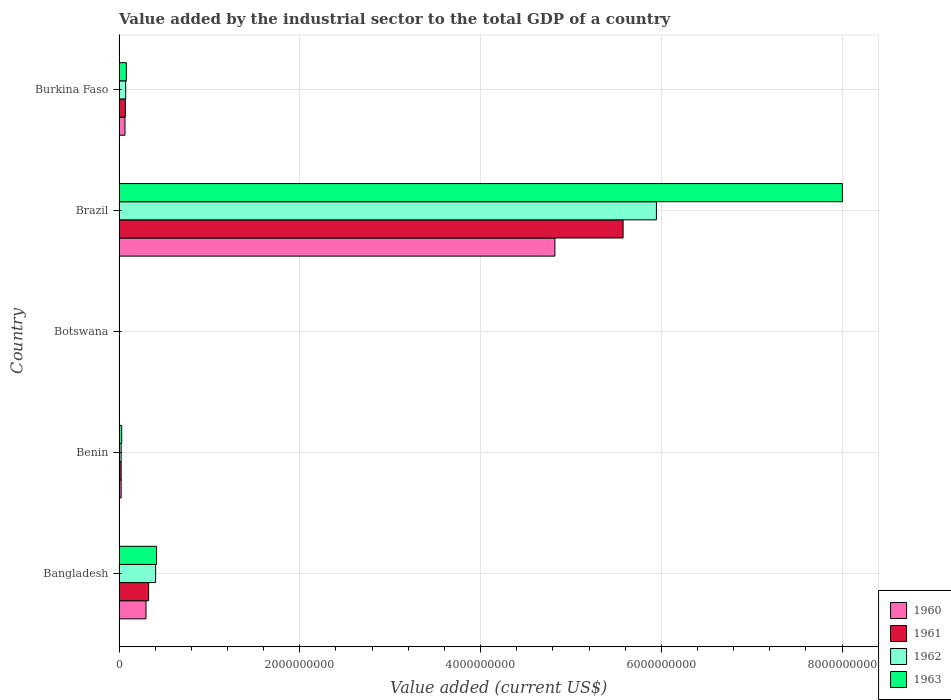What is the label of the 4th group of bars from the top?
Offer a terse response. Benin. In how many cases, is the number of bars for a given country not equal to the number of legend labels?
Keep it short and to the point. 0. What is the value added by the industrial sector to the total GDP in 1960 in Bangladesh?
Keep it short and to the point. 2.98e+08. Across all countries, what is the maximum value added by the industrial sector to the total GDP in 1963?
Your answer should be compact. 8.00e+09. Across all countries, what is the minimum value added by the industrial sector to the total GDP in 1961?
Ensure brevity in your answer.  4.05e+06. In which country was the value added by the industrial sector to the total GDP in 1960 maximum?
Offer a very short reply. Brazil. In which country was the value added by the industrial sector to the total GDP in 1960 minimum?
Provide a short and direct response. Botswana. What is the total value added by the industrial sector to the total GDP in 1960 in the graph?
Make the answer very short. 5.21e+09. What is the difference between the value added by the industrial sector to the total GDP in 1961 in Botswana and that in Burkina Faso?
Provide a succinct answer. -6.56e+07. What is the difference between the value added by the industrial sector to the total GDP in 1963 in Bangladesh and the value added by the industrial sector to the total GDP in 1961 in Benin?
Keep it short and to the point. 3.92e+08. What is the average value added by the industrial sector to the total GDP in 1963 per country?
Provide a succinct answer. 1.71e+09. What is the difference between the value added by the industrial sector to the total GDP in 1960 and value added by the industrial sector to the total GDP in 1962 in Botswana?
Offer a very short reply. -314.81. In how many countries, is the value added by the industrial sector to the total GDP in 1963 greater than 4000000000 US$?
Ensure brevity in your answer.  1. What is the ratio of the value added by the industrial sector to the total GDP in 1962 in Bangladesh to that in Botswana?
Provide a succinct answer. 99.81. Is the value added by the industrial sector to the total GDP in 1961 in Bangladesh less than that in Botswana?
Keep it short and to the point. No. Is the difference between the value added by the industrial sector to the total GDP in 1960 in Bangladesh and Burkina Faso greater than the difference between the value added by the industrial sector to the total GDP in 1962 in Bangladesh and Burkina Faso?
Make the answer very short. No. What is the difference between the highest and the second highest value added by the industrial sector to the total GDP in 1962?
Make the answer very short. 5.54e+09. What is the difference between the highest and the lowest value added by the industrial sector to the total GDP in 1963?
Make the answer very short. 8.00e+09. In how many countries, is the value added by the industrial sector to the total GDP in 1962 greater than the average value added by the industrial sector to the total GDP in 1962 taken over all countries?
Keep it short and to the point. 1. Is the sum of the value added by the industrial sector to the total GDP in 1962 in Botswana and Burkina Faso greater than the maximum value added by the industrial sector to the total GDP in 1960 across all countries?
Your response must be concise. No. Is it the case that in every country, the sum of the value added by the industrial sector to the total GDP in 1960 and value added by the industrial sector to the total GDP in 1962 is greater than the sum of value added by the industrial sector to the total GDP in 1961 and value added by the industrial sector to the total GDP in 1963?
Provide a short and direct response. No. What does the 2nd bar from the top in Bangladesh represents?
Make the answer very short. 1962. Is it the case that in every country, the sum of the value added by the industrial sector to the total GDP in 1960 and value added by the industrial sector to the total GDP in 1962 is greater than the value added by the industrial sector to the total GDP in 1961?
Your answer should be very brief. Yes. How many bars are there?
Your answer should be very brief. 20. What is the difference between two consecutive major ticks on the X-axis?
Provide a short and direct response. 2.00e+09. Does the graph contain any zero values?
Offer a terse response. No. Does the graph contain grids?
Your response must be concise. Yes. Where does the legend appear in the graph?
Provide a succinct answer. Bottom right. How many legend labels are there?
Your response must be concise. 4. What is the title of the graph?
Your answer should be compact. Value added by the industrial sector to the total GDP of a country. Does "1988" appear as one of the legend labels in the graph?
Ensure brevity in your answer.  No. What is the label or title of the X-axis?
Your answer should be very brief. Value added (current US$). What is the Value added (current US$) of 1960 in Bangladesh?
Give a very brief answer. 2.98e+08. What is the Value added (current US$) in 1961 in Bangladesh?
Make the answer very short. 3.27e+08. What is the Value added (current US$) in 1962 in Bangladesh?
Ensure brevity in your answer.  4.05e+08. What is the Value added (current US$) in 1963 in Bangladesh?
Provide a succinct answer. 4.15e+08. What is the Value added (current US$) in 1960 in Benin?
Your answer should be very brief. 2.31e+07. What is the Value added (current US$) in 1961 in Benin?
Your response must be concise. 2.31e+07. What is the Value added (current US$) in 1962 in Benin?
Provide a succinct answer. 2.32e+07. What is the Value added (current US$) in 1963 in Benin?
Give a very brief answer. 2.91e+07. What is the Value added (current US$) of 1960 in Botswana?
Make the answer very short. 4.05e+06. What is the Value added (current US$) in 1961 in Botswana?
Offer a very short reply. 4.05e+06. What is the Value added (current US$) of 1962 in Botswana?
Give a very brief answer. 4.05e+06. What is the Value added (current US$) of 1963 in Botswana?
Keep it short and to the point. 4.04e+06. What is the Value added (current US$) of 1960 in Brazil?
Your answer should be very brief. 4.82e+09. What is the Value added (current US$) in 1961 in Brazil?
Offer a terse response. 5.58e+09. What is the Value added (current US$) of 1962 in Brazil?
Your answer should be very brief. 5.95e+09. What is the Value added (current US$) of 1963 in Brazil?
Ensure brevity in your answer.  8.00e+09. What is the Value added (current US$) of 1960 in Burkina Faso?
Your response must be concise. 6.58e+07. What is the Value added (current US$) of 1961 in Burkina Faso?
Make the answer very short. 6.97e+07. What is the Value added (current US$) in 1962 in Burkina Faso?
Make the answer very short. 7.35e+07. What is the Value added (current US$) of 1963 in Burkina Faso?
Your answer should be compact. 8.13e+07. Across all countries, what is the maximum Value added (current US$) in 1960?
Your answer should be very brief. 4.82e+09. Across all countries, what is the maximum Value added (current US$) of 1961?
Make the answer very short. 5.58e+09. Across all countries, what is the maximum Value added (current US$) in 1962?
Offer a terse response. 5.95e+09. Across all countries, what is the maximum Value added (current US$) of 1963?
Provide a short and direct response. 8.00e+09. Across all countries, what is the minimum Value added (current US$) of 1960?
Ensure brevity in your answer.  4.05e+06. Across all countries, what is the minimum Value added (current US$) in 1961?
Make the answer very short. 4.05e+06. Across all countries, what is the minimum Value added (current US$) of 1962?
Your response must be concise. 4.05e+06. Across all countries, what is the minimum Value added (current US$) of 1963?
Offer a terse response. 4.04e+06. What is the total Value added (current US$) in 1960 in the graph?
Ensure brevity in your answer.  5.21e+09. What is the total Value added (current US$) of 1961 in the graph?
Make the answer very short. 6.00e+09. What is the total Value added (current US$) in 1962 in the graph?
Provide a short and direct response. 6.45e+09. What is the total Value added (current US$) of 1963 in the graph?
Offer a terse response. 8.53e+09. What is the difference between the Value added (current US$) in 1960 in Bangladesh and that in Benin?
Provide a succinct answer. 2.75e+08. What is the difference between the Value added (current US$) in 1961 in Bangladesh and that in Benin?
Your answer should be very brief. 3.04e+08. What is the difference between the Value added (current US$) in 1962 in Bangladesh and that in Benin?
Your answer should be very brief. 3.82e+08. What is the difference between the Value added (current US$) in 1963 in Bangladesh and that in Benin?
Provide a short and direct response. 3.86e+08. What is the difference between the Value added (current US$) of 1960 in Bangladesh and that in Botswana?
Your answer should be compact. 2.94e+08. What is the difference between the Value added (current US$) in 1961 in Bangladesh and that in Botswana?
Your answer should be very brief. 3.23e+08. What is the difference between the Value added (current US$) of 1962 in Bangladesh and that in Botswana?
Keep it short and to the point. 4.01e+08. What is the difference between the Value added (current US$) of 1963 in Bangladesh and that in Botswana?
Your answer should be compact. 4.11e+08. What is the difference between the Value added (current US$) in 1960 in Bangladesh and that in Brazil?
Keep it short and to the point. -4.52e+09. What is the difference between the Value added (current US$) of 1961 in Bangladesh and that in Brazil?
Your answer should be compact. -5.25e+09. What is the difference between the Value added (current US$) in 1962 in Bangladesh and that in Brazil?
Provide a succinct answer. -5.54e+09. What is the difference between the Value added (current US$) of 1963 in Bangladesh and that in Brazil?
Offer a terse response. -7.59e+09. What is the difference between the Value added (current US$) in 1960 in Bangladesh and that in Burkina Faso?
Provide a short and direct response. 2.32e+08. What is the difference between the Value added (current US$) of 1961 in Bangladesh and that in Burkina Faso?
Provide a succinct answer. 2.58e+08. What is the difference between the Value added (current US$) in 1962 in Bangladesh and that in Burkina Faso?
Your response must be concise. 3.31e+08. What is the difference between the Value added (current US$) in 1963 in Bangladesh and that in Burkina Faso?
Offer a terse response. 3.34e+08. What is the difference between the Value added (current US$) in 1960 in Benin and that in Botswana?
Your response must be concise. 1.91e+07. What is the difference between the Value added (current US$) of 1961 in Benin and that in Botswana?
Provide a short and direct response. 1.91e+07. What is the difference between the Value added (current US$) of 1962 in Benin and that in Botswana?
Offer a very short reply. 1.91e+07. What is the difference between the Value added (current US$) of 1963 in Benin and that in Botswana?
Give a very brief answer. 2.51e+07. What is the difference between the Value added (current US$) of 1960 in Benin and that in Brazil?
Ensure brevity in your answer.  -4.80e+09. What is the difference between the Value added (current US$) of 1961 in Benin and that in Brazil?
Offer a terse response. -5.55e+09. What is the difference between the Value added (current US$) in 1962 in Benin and that in Brazil?
Provide a succinct answer. -5.92e+09. What is the difference between the Value added (current US$) of 1963 in Benin and that in Brazil?
Your response must be concise. -7.97e+09. What is the difference between the Value added (current US$) in 1960 in Benin and that in Burkina Faso?
Your answer should be very brief. -4.27e+07. What is the difference between the Value added (current US$) of 1961 in Benin and that in Burkina Faso?
Offer a terse response. -4.66e+07. What is the difference between the Value added (current US$) in 1962 in Benin and that in Burkina Faso?
Provide a succinct answer. -5.04e+07. What is the difference between the Value added (current US$) of 1963 in Benin and that in Burkina Faso?
Offer a very short reply. -5.21e+07. What is the difference between the Value added (current US$) of 1960 in Botswana and that in Brazil?
Keep it short and to the point. -4.82e+09. What is the difference between the Value added (current US$) in 1961 in Botswana and that in Brazil?
Provide a succinct answer. -5.57e+09. What is the difference between the Value added (current US$) of 1962 in Botswana and that in Brazil?
Your answer should be compact. -5.94e+09. What is the difference between the Value added (current US$) of 1963 in Botswana and that in Brazil?
Your answer should be very brief. -8.00e+09. What is the difference between the Value added (current US$) of 1960 in Botswana and that in Burkina Faso?
Offer a terse response. -6.17e+07. What is the difference between the Value added (current US$) of 1961 in Botswana and that in Burkina Faso?
Your answer should be very brief. -6.56e+07. What is the difference between the Value added (current US$) in 1962 in Botswana and that in Burkina Faso?
Your answer should be very brief. -6.95e+07. What is the difference between the Value added (current US$) of 1963 in Botswana and that in Burkina Faso?
Provide a short and direct response. -7.72e+07. What is the difference between the Value added (current US$) of 1960 in Brazil and that in Burkina Faso?
Keep it short and to the point. 4.76e+09. What is the difference between the Value added (current US$) in 1961 in Brazil and that in Burkina Faso?
Ensure brevity in your answer.  5.51e+09. What is the difference between the Value added (current US$) of 1962 in Brazil and that in Burkina Faso?
Make the answer very short. 5.87e+09. What is the difference between the Value added (current US$) in 1963 in Brazil and that in Burkina Faso?
Keep it short and to the point. 7.92e+09. What is the difference between the Value added (current US$) of 1960 in Bangladesh and the Value added (current US$) of 1961 in Benin?
Your response must be concise. 2.75e+08. What is the difference between the Value added (current US$) of 1960 in Bangladesh and the Value added (current US$) of 1962 in Benin?
Offer a very short reply. 2.75e+08. What is the difference between the Value added (current US$) of 1960 in Bangladesh and the Value added (current US$) of 1963 in Benin?
Offer a terse response. 2.69e+08. What is the difference between the Value added (current US$) of 1961 in Bangladesh and the Value added (current US$) of 1962 in Benin?
Offer a terse response. 3.04e+08. What is the difference between the Value added (current US$) in 1961 in Bangladesh and the Value added (current US$) in 1963 in Benin?
Provide a succinct answer. 2.98e+08. What is the difference between the Value added (current US$) of 1962 in Bangladesh and the Value added (current US$) of 1963 in Benin?
Your response must be concise. 3.76e+08. What is the difference between the Value added (current US$) of 1960 in Bangladesh and the Value added (current US$) of 1961 in Botswana?
Ensure brevity in your answer.  2.94e+08. What is the difference between the Value added (current US$) of 1960 in Bangladesh and the Value added (current US$) of 1962 in Botswana?
Keep it short and to the point. 2.94e+08. What is the difference between the Value added (current US$) of 1960 in Bangladesh and the Value added (current US$) of 1963 in Botswana?
Ensure brevity in your answer.  2.94e+08. What is the difference between the Value added (current US$) in 1961 in Bangladesh and the Value added (current US$) in 1962 in Botswana?
Ensure brevity in your answer.  3.23e+08. What is the difference between the Value added (current US$) in 1961 in Bangladesh and the Value added (current US$) in 1963 in Botswana?
Provide a succinct answer. 3.23e+08. What is the difference between the Value added (current US$) in 1962 in Bangladesh and the Value added (current US$) in 1963 in Botswana?
Ensure brevity in your answer.  4.01e+08. What is the difference between the Value added (current US$) in 1960 in Bangladesh and the Value added (current US$) in 1961 in Brazil?
Offer a very short reply. -5.28e+09. What is the difference between the Value added (current US$) in 1960 in Bangladesh and the Value added (current US$) in 1962 in Brazil?
Provide a short and direct response. -5.65e+09. What is the difference between the Value added (current US$) in 1960 in Bangladesh and the Value added (current US$) in 1963 in Brazil?
Provide a succinct answer. -7.71e+09. What is the difference between the Value added (current US$) of 1961 in Bangladesh and the Value added (current US$) of 1962 in Brazil?
Your answer should be compact. -5.62e+09. What is the difference between the Value added (current US$) of 1961 in Bangladesh and the Value added (current US$) of 1963 in Brazil?
Give a very brief answer. -7.68e+09. What is the difference between the Value added (current US$) of 1962 in Bangladesh and the Value added (current US$) of 1963 in Brazil?
Ensure brevity in your answer.  -7.60e+09. What is the difference between the Value added (current US$) of 1960 in Bangladesh and the Value added (current US$) of 1961 in Burkina Faso?
Offer a terse response. 2.28e+08. What is the difference between the Value added (current US$) of 1960 in Bangladesh and the Value added (current US$) of 1962 in Burkina Faso?
Provide a short and direct response. 2.25e+08. What is the difference between the Value added (current US$) in 1960 in Bangladesh and the Value added (current US$) in 1963 in Burkina Faso?
Your answer should be very brief. 2.17e+08. What is the difference between the Value added (current US$) of 1961 in Bangladesh and the Value added (current US$) of 1962 in Burkina Faso?
Provide a succinct answer. 2.54e+08. What is the difference between the Value added (current US$) of 1961 in Bangladesh and the Value added (current US$) of 1963 in Burkina Faso?
Keep it short and to the point. 2.46e+08. What is the difference between the Value added (current US$) of 1962 in Bangladesh and the Value added (current US$) of 1963 in Burkina Faso?
Your answer should be very brief. 3.23e+08. What is the difference between the Value added (current US$) of 1960 in Benin and the Value added (current US$) of 1961 in Botswana?
Your response must be concise. 1.91e+07. What is the difference between the Value added (current US$) in 1960 in Benin and the Value added (current US$) in 1962 in Botswana?
Offer a terse response. 1.91e+07. What is the difference between the Value added (current US$) of 1960 in Benin and the Value added (current US$) of 1963 in Botswana?
Provide a short and direct response. 1.91e+07. What is the difference between the Value added (current US$) in 1961 in Benin and the Value added (current US$) in 1962 in Botswana?
Keep it short and to the point. 1.91e+07. What is the difference between the Value added (current US$) in 1961 in Benin and the Value added (current US$) in 1963 in Botswana?
Offer a very short reply. 1.91e+07. What is the difference between the Value added (current US$) of 1962 in Benin and the Value added (current US$) of 1963 in Botswana?
Provide a succinct answer. 1.91e+07. What is the difference between the Value added (current US$) in 1960 in Benin and the Value added (current US$) in 1961 in Brazil?
Offer a very short reply. -5.55e+09. What is the difference between the Value added (current US$) of 1960 in Benin and the Value added (current US$) of 1962 in Brazil?
Provide a succinct answer. -5.92e+09. What is the difference between the Value added (current US$) of 1960 in Benin and the Value added (current US$) of 1963 in Brazil?
Provide a succinct answer. -7.98e+09. What is the difference between the Value added (current US$) in 1961 in Benin and the Value added (current US$) in 1962 in Brazil?
Provide a succinct answer. -5.92e+09. What is the difference between the Value added (current US$) in 1961 in Benin and the Value added (current US$) in 1963 in Brazil?
Your answer should be compact. -7.98e+09. What is the difference between the Value added (current US$) of 1962 in Benin and the Value added (current US$) of 1963 in Brazil?
Provide a short and direct response. -7.98e+09. What is the difference between the Value added (current US$) of 1960 in Benin and the Value added (current US$) of 1961 in Burkina Faso?
Your answer should be very brief. -4.65e+07. What is the difference between the Value added (current US$) in 1960 in Benin and the Value added (current US$) in 1962 in Burkina Faso?
Provide a short and direct response. -5.04e+07. What is the difference between the Value added (current US$) of 1960 in Benin and the Value added (current US$) of 1963 in Burkina Faso?
Provide a short and direct response. -5.81e+07. What is the difference between the Value added (current US$) in 1961 in Benin and the Value added (current US$) in 1962 in Burkina Faso?
Your answer should be very brief. -5.04e+07. What is the difference between the Value added (current US$) of 1961 in Benin and the Value added (current US$) of 1963 in Burkina Faso?
Give a very brief answer. -5.81e+07. What is the difference between the Value added (current US$) in 1962 in Benin and the Value added (current US$) in 1963 in Burkina Faso?
Provide a succinct answer. -5.81e+07. What is the difference between the Value added (current US$) of 1960 in Botswana and the Value added (current US$) of 1961 in Brazil?
Your response must be concise. -5.57e+09. What is the difference between the Value added (current US$) of 1960 in Botswana and the Value added (current US$) of 1962 in Brazil?
Keep it short and to the point. -5.94e+09. What is the difference between the Value added (current US$) of 1960 in Botswana and the Value added (current US$) of 1963 in Brazil?
Keep it short and to the point. -8.00e+09. What is the difference between the Value added (current US$) in 1961 in Botswana and the Value added (current US$) in 1962 in Brazil?
Your response must be concise. -5.94e+09. What is the difference between the Value added (current US$) in 1961 in Botswana and the Value added (current US$) in 1963 in Brazil?
Your response must be concise. -8.00e+09. What is the difference between the Value added (current US$) in 1962 in Botswana and the Value added (current US$) in 1963 in Brazil?
Keep it short and to the point. -8.00e+09. What is the difference between the Value added (current US$) in 1960 in Botswana and the Value added (current US$) in 1961 in Burkina Faso?
Give a very brief answer. -6.56e+07. What is the difference between the Value added (current US$) of 1960 in Botswana and the Value added (current US$) of 1962 in Burkina Faso?
Your answer should be compact. -6.95e+07. What is the difference between the Value added (current US$) in 1960 in Botswana and the Value added (current US$) in 1963 in Burkina Faso?
Offer a terse response. -7.72e+07. What is the difference between the Value added (current US$) in 1961 in Botswana and the Value added (current US$) in 1962 in Burkina Faso?
Give a very brief answer. -6.95e+07. What is the difference between the Value added (current US$) in 1961 in Botswana and the Value added (current US$) in 1963 in Burkina Faso?
Make the answer very short. -7.72e+07. What is the difference between the Value added (current US$) of 1962 in Botswana and the Value added (current US$) of 1963 in Burkina Faso?
Give a very brief answer. -7.72e+07. What is the difference between the Value added (current US$) in 1960 in Brazil and the Value added (current US$) in 1961 in Burkina Faso?
Provide a short and direct response. 4.75e+09. What is the difference between the Value added (current US$) of 1960 in Brazil and the Value added (current US$) of 1962 in Burkina Faso?
Offer a terse response. 4.75e+09. What is the difference between the Value added (current US$) of 1960 in Brazil and the Value added (current US$) of 1963 in Burkina Faso?
Offer a terse response. 4.74e+09. What is the difference between the Value added (current US$) in 1961 in Brazil and the Value added (current US$) in 1962 in Burkina Faso?
Offer a terse response. 5.50e+09. What is the difference between the Value added (current US$) of 1961 in Brazil and the Value added (current US$) of 1963 in Burkina Faso?
Give a very brief answer. 5.50e+09. What is the difference between the Value added (current US$) in 1962 in Brazil and the Value added (current US$) in 1963 in Burkina Faso?
Your answer should be very brief. 5.86e+09. What is the average Value added (current US$) of 1960 per country?
Give a very brief answer. 1.04e+09. What is the average Value added (current US$) of 1961 per country?
Your response must be concise. 1.20e+09. What is the average Value added (current US$) of 1962 per country?
Provide a succinct answer. 1.29e+09. What is the average Value added (current US$) in 1963 per country?
Offer a very short reply. 1.71e+09. What is the difference between the Value added (current US$) of 1960 and Value added (current US$) of 1961 in Bangladesh?
Provide a short and direct response. -2.92e+07. What is the difference between the Value added (current US$) in 1960 and Value added (current US$) in 1962 in Bangladesh?
Your response must be concise. -1.07e+08. What is the difference between the Value added (current US$) of 1960 and Value added (current US$) of 1963 in Bangladesh?
Make the answer very short. -1.17e+08. What is the difference between the Value added (current US$) in 1961 and Value added (current US$) in 1962 in Bangladesh?
Keep it short and to the point. -7.74e+07. What is the difference between the Value added (current US$) in 1961 and Value added (current US$) in 1963 in Bangladesh?
Provide a succinct answer. -8.78e+07. What is the difference between the Value added (current US$) in 1962 and Value added (current US$) in 1963 in Bangladesh?
Your answer should be compact. -1.05e+07. What is the difference between the Value added (current US$) of 1960 and Value added (current US$) of 1961 in Benin?
Your response must be concise. 6130.83. What is the difference between the Value added (current US$) in 1960 and Value added (current US$) in 1962 in Benin?
Keep it short and to the point. -1.71e+04. What is the difference between the Value added (current US$) of 1960 and Value added (current US$) of 1963 in Benin?
Your answer should be very brief. -5.99e+06. What is the difference between the Value added (current US$) in 1961 and Value added (current US$) in 1962 in Benin?
Make the answer very short. -2.32e+04. What is the difference between the Value added (current US$) in 1961 and Value added (current US$) in 1963 in Benin?
Offer a very short reply. -6.00e+06. What is the difference between the Value added (current US$) in 1962 and Value added (current US$) in 1963 in Benin?
Give a very brief answer. -5.97e+06. What is the difference between the Value added (current US$) of 1960 and Value added (current US$) of 1961 in Botswana?
Offer a very short reply. 7791.27. What is the difference between the Value added (current US$) of 1960 and Value added (current US$) of 1962 in Botswana?
Keep it short and to the point. -314.81. What is the difference between the Value added (current US$) in 1960 and Value added (current US$) in 1963 in Botswana?
Your answer should be compact. 1.11e+04. What is the difference between the Value added (current US$) of 1961 and Value added (current US$) of 1962 in Botswana?
Provide a succinct answer. -8106.08. What is the difference between the Value added (current US$) of 1961 and Value added (current US$) of 1963 in Botswana?
Provide a succinct answer. 3353.04. What is the difference between the Value added (current US$) in 1962 and Value added (current US$) in 1963 in Botswana?
Keep it short and to the point. 1.15e+04. What is the difference between the Value added (current US$) in 1960 and Value added (current US$) in 1961 in Brazil?
Offer a terse response. -7.55e+08. What is the difference between the Value added (current US$) of 1960 and Value added (current US$) of 1962 in Brazil?
Your answer should be compact. -1.12e+09. What is the difference between the Value added (current US$) in 1960 and Value added (current US$) in 1963 in Brazil?
Provide a succinct answer. -3.18e+09. What is the difference between the Value added (current US$) of 1961 and Value added (current US$) of 1962 in Brazil?
Your response must be concise. -3.69e+08. What is the difference between the Value added (current US$) of 1961 and Value added (current US$) of 1963 in Brazil?
Your answer should be compact. -2.43e+09. What is the difference between the Value added (current US$) in 1962 and Value added (current US$) in 1963 in Brazil?
Keep it short and to the point. -2.06e+09. What is the difference between the Value added (current US$) of 1960 and Value added (current US$) of 1961 in Burkina Faso?
Ensure brevity in your answer.  -3.88e+06. What is the difference between the Value added (current US$) in 1960 and Value added (current US$) in 1962 in Burkina Faso?
Your answer should be compact. -7.71e+06. What is the difference between the Value added (current US$) of 1960 and Value added (current US$) of 1963 in Burkina Faso?
Make the answer very short. -1.55e+07. What is the difference between the Value added (current US$) in 1961 and Value added (current US$) in 1962 in Burkina Faso?
Provide a short and direct response. -3.83e+06. What is the difference between the Value added (current US$) of 1961 and Value added (current US$) of 1963 in Burkina Faso?
Provide a succinct answer. -1.16e+07. What is the difference between the Value added (current US$) of 1962 and Value added (current US$) of 1963 in Burkina Faso?
Your answer should be compact. -7.75e+06. What is the ratio of the Value added (current US$) of 1960 in Bangladesh to that in Benin?
Ensure brevity in your answer.  12.89. What is the ratio of the Value added (current US$) in 1961 in Bangladesh to that in Benin?
Keep it short and to the point. 14.15. What is the ratio of the Value added (current US$) in 1962 in Bangladesh to that in Benin?
Your response must be concise. 17.48. What is the ratio of the Value added (current US$) of 1963 in Bangladesh to that in Benin?
Provide a succinct answer. 14.26. What is the ratio of the Value added (current US$) in 1960 in Bangladesh to that in Botswana?
Keep it short and to the point. 73.54. What is the ratio of the Value added (current US$) in 1961 in Bangladesh to that in Botswana?
Keep it short and to the point. 80.89. What is the ratio of the Value added (current US$) of 1962 in Bangladesh to that in Botswana?
Make the answer very short. 99.81. What is the ratio of the Value added (current US$) of 1963 in Bangladesh to that in Botswana?
Your answer should be compact. 102.69. What is the ratio of the Value added (current US$) in 1960 in Bangladesh to that in Brazil?
Offer a terse response. 0.06. What is the ratio of the Value added (current US$) in 1961 in Bangladesh to that in Brazil?
Provide a succinct answer. 0.06. What is the ratio of the Value added (current US$) in 1962 in Bangladesh to that in Brazil?
Provide a succinct answer. 0.07. What is the ratio of the Value added (current US$) in 1963 in Bangladesh to that in Brazil?
Offer a terse response. 0.05. What is the ratio of the Value added (current US$) of 1960 in Bangladesh to that in Burkina Faso?
Keep it short and to the point. 4.53. What is the ratio of the Value added (current US$) in 1961 in Bangladesh to that in Burkina Faso?
Keep it short and to the point. 4.7. What is the ratio of the Value added (current US$) in 1962 in Bangladesh to that in Burkina Faso?
Provide a short and direct response. 5.5. What is the ratio of the Value added (current US$) of 1963 in Bangladesh to that in Burkina Faso?
Give a very brief answer. 5.11. What is the ratio of the Value added (current US$) in 1960 in Benin to that in Botswana?
Provide a succinct answer. 5.71. What is the ratio of the Value added (current US$) in 1961 in Benin to that in Botswana?
Your response must be concise. 5.72. What is the ratio of the Value added (current US$) of 1962 in Benin to that in Botswana?
Give a very brief answer. 5.71. What is the ratio of the Value added (current US$) of 1963 in Benin to that in Botswana?
Your answer should be very brief. 7.2. What is the ratio of the Value added (current US$) of 1960 in Benin to that in Brazil?
Keep it short and to the point. 0. What is the ratio of the Value added (current US$) of 1961 in Benin to that in Brazil?
Your response must be concise. 0. What is the ratio of the Value added (current US$) of 1962 in Benin to that in Brazil?
Ensure brevity in your answer.  0. What is the ratio of the Value added (current US$) of 1963 in Benin to that in Brazil?
Provide a succinct answer. 0. What is the ratio of the Value added (current US$) of 1960 in Benin to that in Burkina Faso?
Ensure brevity in your answer.  0.35. What is the ratio of the Value added (current US$) of 1961 in Benin to that in Burkina Faso?
Provide a succinct answer. 0.33. What is the ratio of the Value added (current US$) in 1962 in Benin to that in Burkina Faso?
Offer a very short reply. 0.31. What is the ratio of the Value added (current US$) in 1963 in Benin to that in Burkina Faso?
Offer a very short reply. 0.36. What is the ratio of the Value added (current US$) in 1960 in Botswana to that in Brazil?
Ensure brevity in your answer.  0. What is the ratio of the Value added (current US$) in 1961 in Botswana to that in Brazil?
Give a very brief answer. 0. What is the ratio of the Value added (current US$) in 1962 in Botswana to that in Brazil?
Make the answer very short. 0. What is the ratio of the Value added (current US$) of 1960 in Botswana to that in Burkina Faso?
Offer a very short reply. 0.06. What is the ratio of the Value added (current US$) in 1961 in Botswana to that in Burkina Faso?
Provide a short and direct response. 0.06. What is the ratio of the Value added (current US$) of 1962 in Botswana to that in Burkina Faso?
Your response must be concise. 0.06. What is the ratio of the Value added (current US$) in 1963 in Botswana to that in Burkina Faso?
Offer a terse response. 0.05. What is the ratio of the Value added (current US$) of 1960 in Brazil to that in Burkina Faso?
Your response must be concise. 73.29. What is the ratio of the Value added (current US$) of 1961 in Brazil to that in Burkina Faso?
Provide a short and direct response. 80.04. What is the ratio of the Value added (current US$) in 1962 in Brazil to that in Burkina Faso?
Provide a short and direct response. 80.89. What is the ratio of the Value added (current US$) in 1963 in Brazil to that in Burkina Faso?
Offer a terse response. 98.49. What is the difference between the highest and the second highest Value added (current US$) of 1960?
Offer a terse response. 4.52e+09. What is the difference between the highest and the second highest Value added (current US$) in 1961?
Make the answer very short. 5.25e+09. What is the difference between the highest and the second highest Value added (current US$) in 1962?
Offer a very short reply. 5.54e+09. What is the difference between the highest and the second highest Value added (current US$) in 1963?
Offer a terse response. 7.59e+09. What is the difference between the highest and the lowest Value added (current US$) of 1960?
Give a very brief answer. 4.82e+09. What is the difference between the highest and the lowest Value added (current US$) of 1961?
Your answer should be compact. 5.57e+09. What is the difference between the highest and the lowest Value added (current US$) of 1962?
Make the answer very short. 5.94e+09. What is the difference between the highest and the lowest Value added (current US$) of 1963?
Offer a terse response. 8.00e+09. 